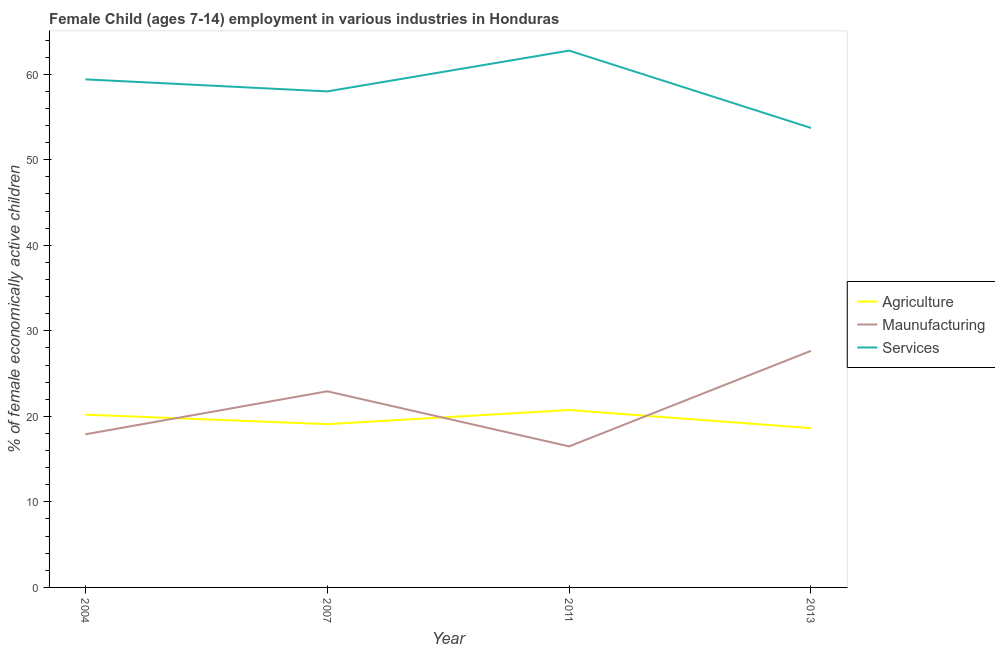What is the percentage of economically active children in manufacturing in 2004?
Provide a short and direct response. 17.9. Across all years, what is the maximum percentage of economically active children in services?
Offer a terse response. 62.76. Across all years, what is the minimum percentage of economically active children in services?
Make the answer very short. 53.72. In which year was the percentage of economically active children in manufacturing maximum?
Offer a very short reply. 2013. In which year was the percentage of economically active children in services minimum?
Your response must be concise. 2013. What is the total percentage of economically active children in agriculture in the graph?
Provide a succinct answer. 78.65. What is the difference between the percentage of economically active children in services in 2004 and that in 2011?
Provide a short and direct response. -3.36. What is the difference between the percentage of economically active children in manufacturing in 2013 and the percentage of economically active children in agriculture in 2011?
Make the answer very short. 6.92. What is the average percentage of economically active children in services per year?
Your answer should be very brief. 58.47. In the year 2007, what is the difference between the percentage of economically active children in services and percentage of economically active children in manufacturing?
Provide a succinct answer. 35.06. What is the ratio of the percentage of economically active children in services in 2007 to that in 2013?
Provide a short and direct response. 1.08. Is the percentage of economically active children in manufacturing in 2004 less than that in 2007?
Offer a terse response. Yes. Is the difference between the percentage of economically active children in manufacturing in 2011 and 2013 greater than the difference between the percentage of economically active children in services in 2011 and 2013?
Your response must be concise. No. What is the difference between the highest and the second highest percentage of economically active children in manufacturing?
Your answer should be very brief. 4.73. What is the difference between the highest and the lowest percentage of economically active children in services?
Offer a terse response. 9.04. In how many years, is the percentage of economically active children in services greater than the average percentage of economically active children in services taken over all years?
Offer a very short reply. 2. Is it the case that in every year, the sum of the percentage of economically active children in agriculture and percentage of economically active children in manufacturing is greater than the percentage of economically active children in services?
Your response must be concise. No. Does the percentage of economically active children in services monotonically increase over the years?
Provide a short and direct response. No. Is the percentage of economically active children in manufacturing strictly less than the percentage of economically active children in agriculture over the years?
Keep it short and to the point. No. How many years are there in the graph?
Your answer should be very brief. 4. Does the graph contain grids?
Ensure brevity in your answer.  No. How many legend labels are there?
Your answer should be very brief. 3. How are the legend labels stacked?
Offer a very short reply. Vertical. What is the title of the graph?
Provide a succinct answer. Female Child (ages 7-14) employment in various industries in Honduras. What is the label or title of the Y-axis?
Offer a very short reply. % of female economically active children. What is the % of female economically active children in Agriculture in 2004?
Provide a short and direct response. 20.2. What is the % of female economically active children in Maunufacturing in 2004?
Ensure brevity in your answer.  17.9. What is the % of female economically active children of Services in 2004?
Your answer should be compact. 59.4. What is the % of female economically active children in Agriculture in 2007?
Your response must be concise. 19.09. What is the % of female economically active children in Maunufacturing in 2007?
Your answer should be compact. 22.93. What is the % of female economically active children in Services in 2007?
Ensure brevity in your answer.  57.99. What is the % of female economically active children of Agriculture in 2011?
Your answer should be compact. 20.74. What is the % of female economically active children in Maunufacturing in 2011?
Your answer should be very brief. 16.49. What is the % of female economically active children in Services in 2011?
Ensure brevity in your answer.  62.76. What is the % of female economically active children in Agriculture in 2013?
Make the answer very short. 18.62. What is the % of female economically active children of Maunufacturing in 2013?
Ensure brevity in your answer.  27.66. What is the % of female economically active children of Services in 2013?
Offer a terse response. 53.72. Across all years, what is the maximum % of female economically active children in Agriculture?
Give a very brief answer. 20.74. Across all years, what is the maximum % of female economically active children in Maunufacturing?
Provide a succinct answer. 27.66. Across all years, what is the maximum % of female economically active children of Services?
Offer a very short reply. 62.76. Across all years, what is the minimum % of female economically active children in Agriculture?
Give a very brief answer. 18.62. Across all years, what is the minimum % of female economically active children in Maunufacturing?
Provide a short and direct response. 16.49. Across all years, what is the minimum % of female economically active children in Services?
Keep it short and to the point. 53.72. What is the total % of female economically active children in Agriculture in the graph?
Your answer should be compact. 78.65. What is the total % of female economically active children in Maunufacturing in the graph?
Make the answer very short. 84.98. What is the total % of female economically active children of Services in the graph?
Your response must be concise. 233.87. What is the difference between the % of female economically active children of Agriculture in 2004 and that in 2007?
Your answer should be compact. 1.11. What is the difference between the % of female economically active children of Maunufacturing in 2004 and that in 2007?
Your answer should be very brief. -5.03. What is the difference between the % of female economically active children in Services in 2004 and that in 2007?
Provide a short and direct response. 1.41. What is the difference between the % of female economically active children in Agriculture in 2004 and that in 2011?
Make the answer very short. -0.54. What is the difference between the % of female economically active children in Maunufacturing in 2004 and that in 2011?
Your answer should be very brief. 1.41. What is the difference between the % of female economically active children of Services in 2004 and that in 2011?
Your response must be concise. -3.36. What is the difference between the % of female economically active children of Agriculture in 2004 and that in 2013?
Your response must be concise. 1.58. What is the difference between the % of female economically active children in Maunufacturing in 2004 and that in 2013?
Your response must be concise. -9.76. What is the difference between the % of female economically active children of Services in 2004 and that in 2013?
Provide a short and direct response. 5.68. What is the difference between the % of female economically active children in Agriculture in 2007 and that in 2011?
Make the answer very short. -1.65. What is the difference between the % of female economically active children in Maunufacturing in 2007 and that in 2011?
Keep it short and to the point. 6.44. What is the difference between the % of female economically active children in Services in 2007 and that in 2011?
Make the answer very short. -4.77. What is the difference between the % of female economically active children of Agriculture in 2007 and that in 2013?
Keep it short and to the point. 0.47. What is the difference between the % of female economically active children in Maunufacturing in 2007 and that in 2013?
Offer a terse response. -4.73. What is the difference between the % of female economically active children of Services in 2007 and that in 2013?
Ensure brevity in your answer.  4.27. What is the difference between the % of female economically active children of Agriculture in 2011 and that in 2013?
Your response must be concise. 2.12. What is the difference between the % of female economically active children of Maunufacturing in 2011 and that in 2013?
Your answer should be very brief. -11.17. What is the difference between the % of female economically active children of Services in 2011 and that in 2013?
Keep it short and to the point. 9.04. What is the difference between the % of female economically active children in Agriculture in 2004 and the % of female economically active children in Maunufacturing in 2007?
Offer a very short reply. -2.73. What is the difference between the % of female economically active children of Agriculture in 2004 and the % of female economically active children of Services in 2007?
Keep it short and to the point. -37.79. What is the difference between the % of female economically active children in Maunufacturing in 2004 and the % of female economically active children in Services in 2007?
Your response must be concise. -40.09. What is the difference between the % of female economically active children of Agriculture in 2004 and the % of female economically active children of Maunufacturing in 2011?
Keep it short and to the point. 3.71. What is the difference between the % of female economically active children in Agriculture in 2004 and the % of female economically active children in Services in 2011?
Make the answer very short. -42.56. What is the difference between the % of female economically active children in Maunufacturing in 2004 and the % of female economically active children in Services in 2011?
Your response must be concise. -44.86. What is the difference between the % of female economically active children of Agriculture in 2004 and the % of female economically active children of Maunufacturing in 2013?
Ensure brevity in your answer.  -7.46. What is the difference between the % of female economically active children of Agriculture in 2004 and the % of female economically active children of Services in 2013?
Provide a succinct answer. -33.52. What is the difference between the % of female economically active children of Maunufacturing in 2004 and the % of female economically active children of Services in 2013?
Your response must be concise. -35.82. What is the difference between the % of female economically active children in Agriculture in 2007 and the % of female economically active children in Services in 2011?
Ensure brevity in your answer.  -43.67. What is the difference between the % of female economically active children in Maunufacturing in 2007 and the % of female economically active children in Services in 2011?
Your answer should be compact. -39.83. What is the difference between the % of female economically active children in Agriculture in 2007 and the % of female economically active children in Maunufacturing in 2013?
Your answer should be compact. -8.57. What is the difference between the % of female economically active children of Agriculture in 2007 and the % of female economically active children of Services in 2013?
Give a very brief answer. -34.63. What is the difference between the % of female economically active children of Maunufacturing in 2007 and the % of female economically active children of Services in 2013?
Provide a succinct answer. -30.79. What is the difference between the % of female economically active children of Agriculture in 2011 and the % of female economically active children of Maunufacturing in 2013?
Provide a succinct answer. -6.92. What is the difference between the % of female economically active children of Agriculture in 2011 and the % of female economically active children of Services in 2013?
Offer a terse response. -32.98. What is the difference between the % of female economically active children in Maunufacturing in 2011 and the % of female economically active children in Services in 2013?
Keep it short and to the point. -37.23. What is the average % of female economically active children of Agriculture per year?
Offer a terse response. 19.66. What is the average % of female economically active children of Maunufacturing per year?
Keep it short and to the point. 21.25. What is the average % of female economically active children in Services per year?
Offer a very short reply. 58.47. In the year 2004, what is the difference between the % of female economically active children of Agriculture and % of female economically active children of Services?
Provide a succinct answer. -39.2. In the year 2004, what is the difference between the % of female economically active children in Maunufacturing and % of female economically active children in Services?
Your response must be concise. -41.5. In the year 2007, what is the difference between the % of female economically active children in Agriculture and % of female economically active children in Maunufacturing?
Make the answer very short. -3.84. In the year 2007, what is the difference between the % of female economically active children of Agriculture and % of female economically active children of Services?
Make the answer very short. -38.9. In the year 2007, what is the difference between the % of female economically active children in Maunufacturing and % of female economically active children in Services?
Your answer should be compact. -35.06. In the year 2011, what is the difference between the % of female economically active children of Agriculture and % of female economically active children of Maunufacturing?
Provide a short and direct response. 4.25. In the year 2011, what is the difference between the % of female economically active children of Agriculture and % of female economically active children of Services?
Offer a very short reply. -42.02. In the year 2011, what is the difference between the % of female economically active children in Maunufacturing and % of female economically active children in Services?
Your response must be concise. -46.27. In the year 2013, what is the difference between the % of female economically active children in Agriculture and % of female economically active children in Maunufacturing?
Provide a short and direct response. -9.04. In the year 2013, what is the difference between the % of female economically active children of Agriculture and % of female economically active children of Services?
Your answer should be very brief. -35.1. In the year 2013, what is the difference between the % of female economically active children in Maunufacturing and % of female economically active children in Services?
Ensure brevity in your answer.  -26.06. What is the ratio of the % of female economically active children of Agriculture in 2004 to that in 2007?
Offer a terse response. 1.06. What is the ratio of the % of female economically active children of Maunufacturing in 2004 to that in 2007?
Offer a very short reply. 0.78. What is the ratio of the % of female economically active children of Services in 2004 to that in 2007?
Make the answer very short. 1.02. What is the ratio of the % of female economically active children of Maunufacturing in 2004 to that in 2011?
Ensure brevity in your answer.  1.09. What is the ratio of the % of female economically active children in Services in 2004 to that in 2011?
Your response must be concise. 0.95. What is the ratio of the % of female economically active children in Agriculture in 2004 to that in 2013?
Offer a terse response. 1.08. What is the ratio of the % of female economically active children of Maunufacturing in 2004 to that in 2013?
Your response must be concise. 0.65. What is the ratio of the % of female economically active children of Services in 2004 to that in 2013?
Your answer should be compact. 1.11. What is the ratio of the % of female economically active children of Agriculture in 2007 to that in 2011?
Offer a terse response. 0.92. What is the ratio of the % of female economically active children in Maunufacturing in 2007 to that in 2011?
Your response must be concise. 1.39. What is the ratio of the % of female economically active children of Services in 2007 to that in 2011?
Keep it short and to the point. 0.92. What is the ratio of the % of female economically active children of Agriculture in 2007 to that in 2013?
Offer a terse response. 1.03. What is the ratio of the % of female economically active children of Maunufacturing in 2007 to that in 2013?
Ensure brevity in your answer.  0.83. What is the ratio of the % of female economically active children of Services in 2007 to that in 2013?
Offer a very short reply. 1.08. What is the ratio of the % of female economically active children of Agriculture in 2011 to that in 2013?
Your answer should be very brief. 1.11. What is the ratio of the % of female economically active children in Maunufacturing in 2011 to that in 2013?
Offer a very short reply. 0.6. What is the ratio of the % of female economically active children in Services in 2011 to that in 2013?
Make the answer very short. 1.17. What is the difference between the highest and the second highest % of female economically active children of Agriculture?
Offer a very short reply. 0.54. What is the difference between the highest and the second highest % of female economically active children of Maunufacturing?
Offer a very short reply. 4.73. What is the difference between the highest and the second highest % of female economically active children in Services?
Provide a succinct answer. 3.36. What is the difference between the highest and the lowest % of female economically active children of Agriculture?
Offer a very short reply. 2.12. What is the difference between the highest and the lowest % of female economically active children in Maunufacturing?
Your answer should be compact. 11.17. What is the difference between the highest and the lowest % of female economically active children of Services?
Offer a very short reply. 9.04. 